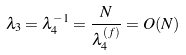Convert formula to latex. <formula><loc_0><loc_0><loc_500><loc_500>\lambda _ { 3 } = \lambda _ { 4 } ^ { - 1 } = \frac { N } { \lambda _ { 4 } ^ { ( f ) } } = O ( N )</formula> 